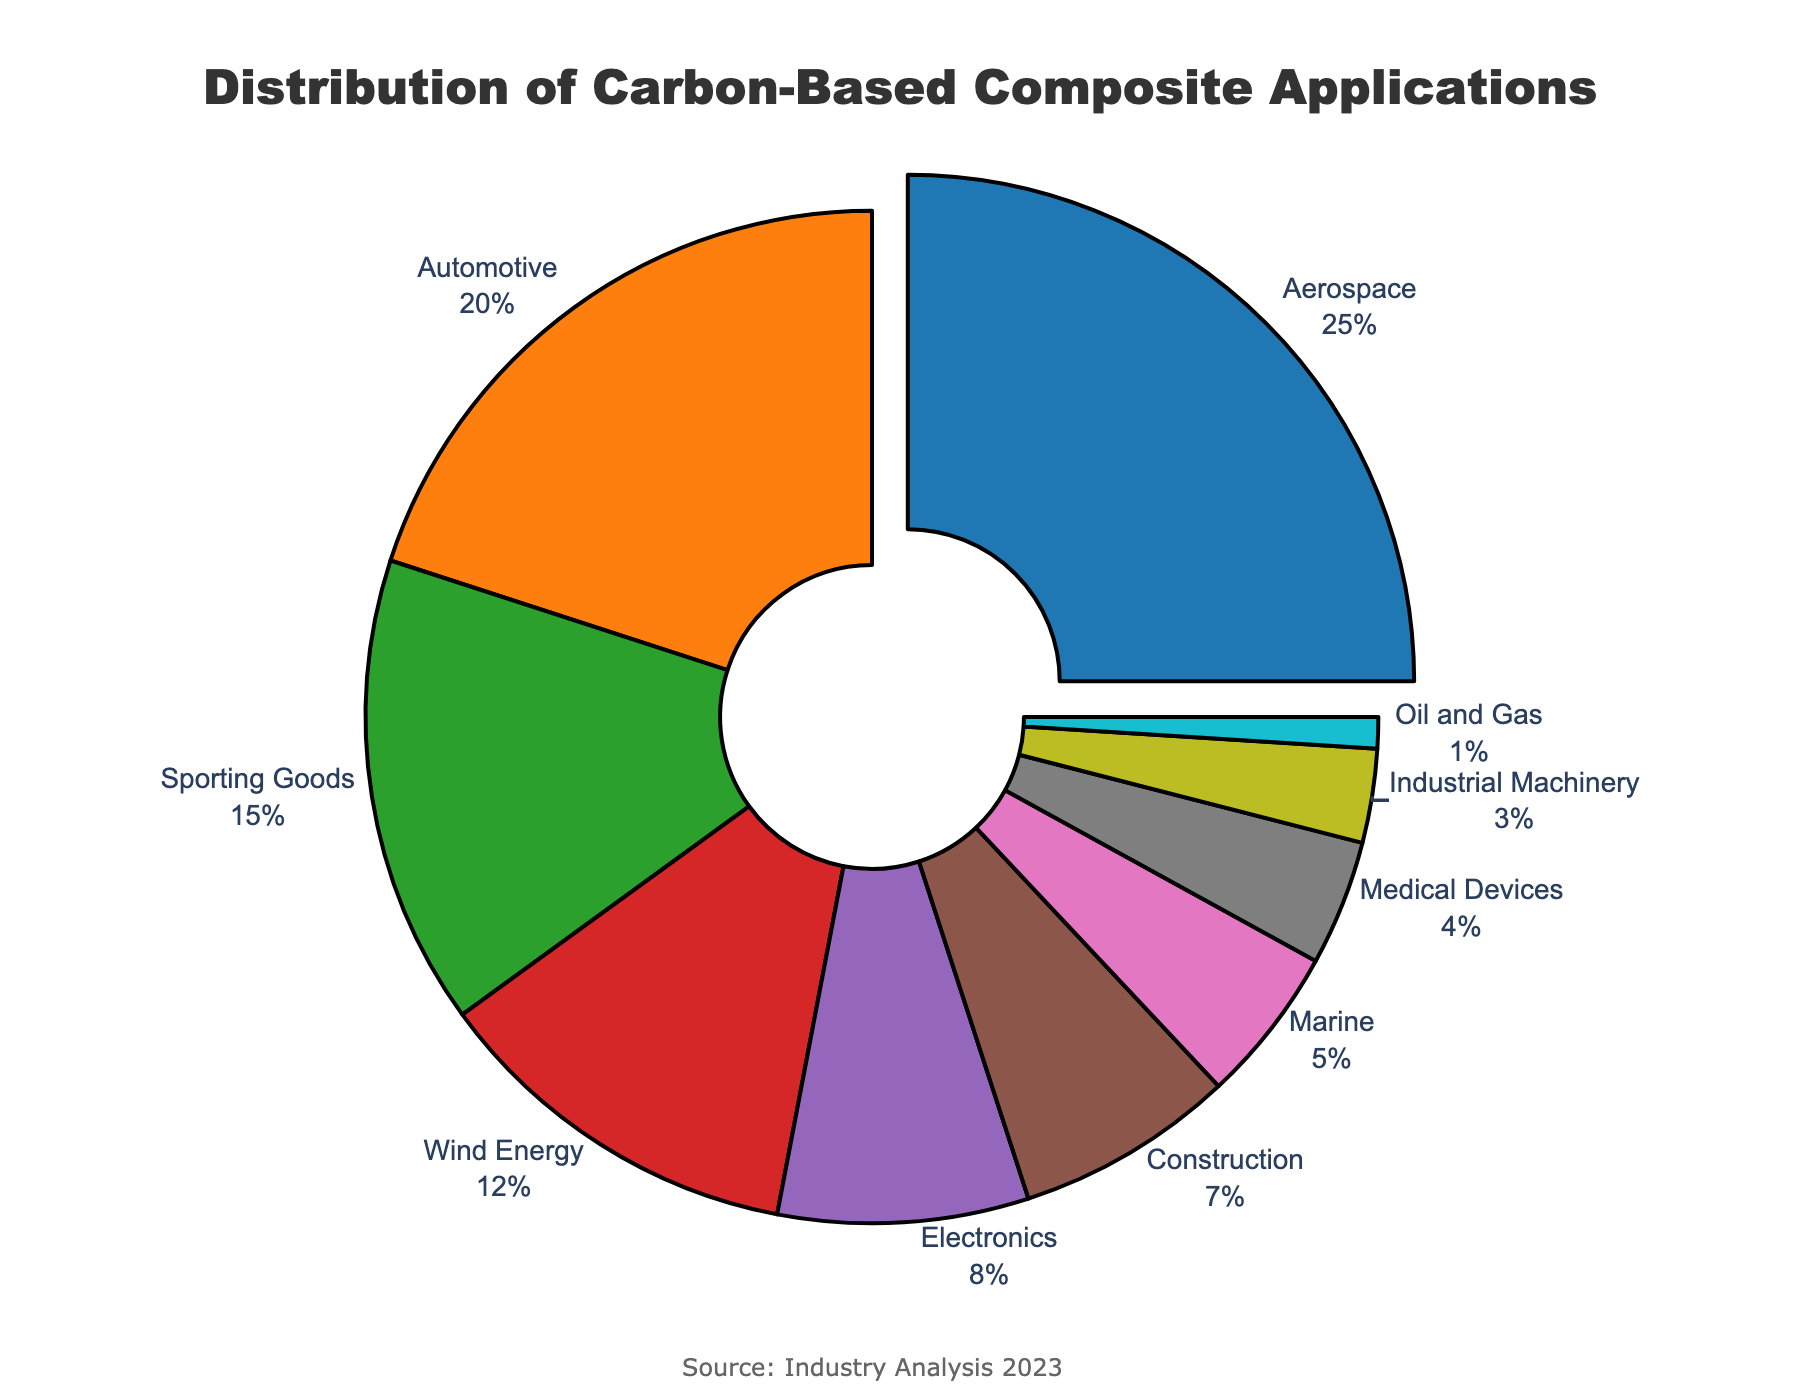What's the largest industry using carbon-based composites? The largest industry is identified by finding the industry segment with the highest percentage. The figure indicates that Aerospace has the highest percentage, 25%.
Answer: Aerospace What's the sum of the percentages for Automotive and Sporting Goods industries? Add the provided percentages for both industries: Automotive (20%) and Sporting Goods (15%). So, 20 + 15 = 35.
Answer: 35% What is the difference in percentage between Wind Energy and Electronics applications? Subtract the percentage of Electronics from Wind Energy: Wind Energy (12%) - Electronics (8%) = 4.
Answer: 4% Which industries have a percentage less than Marine? Identify industries with a percentage lower than Marine's 5%: Medical Devices (4%), Industrial Machinery (3%), and Oil and Gas (1%).
Answer: Medical Devices, Industrial Machinery, Oil and Gas What's the combined percentage for the top three industries? Sum the percentages of the top three industries: Aerospace (25%), Automotive (20%), and Sporting Goods (15%). So, 25 + 20 + 15 = 60.
Answer: 60% How much more significant is the Automotive industry compared to the Medical Devices industry in terms of percentage? Subtract the Medical Devices percentage from the Automotive percentage: Automotive (20%) - Medical Devices (4%) = 16.
Answer: 16% What's the average percentage for the industries with less than 10% usage of carbon-based composites? Sum the percentages of all industries with less than 10%, then divide by the number of these industries: (Electronics (8%) + Construction (7%) + Marine (5%) + Medical Devices (4%) + Industrial Machinery (3%) + Oil and Gas (1%)) / 6 = 28 / 6 ≈ 4.67.
Answer: 4.67% Which industry has the smallest share of carbon-based composites, and what is its percentage? The smallest share is identified by finding the industry with the lowest percentage, which is Oil and Gas at 1%.
Answer: Oil and Gas, 1% List the industries that use more carbon-based composites than the Electronics industry. Identify all industries with a higher percentage than Electronics (8%): Aerospace (25%), Automotive (20%), Sporting Goods (15%), Wind Energy (12%).
Answer: Aerospace, Automotive, Sporting Goods, Wind Energy What are the visual attributes of the largest sector in the pie chart in terms of color? The largest sector, Aerospace (25%), is visually represented with a specific color. According to the color mapping, Aerospace is represented in a blue shade.
Answer: Blue 